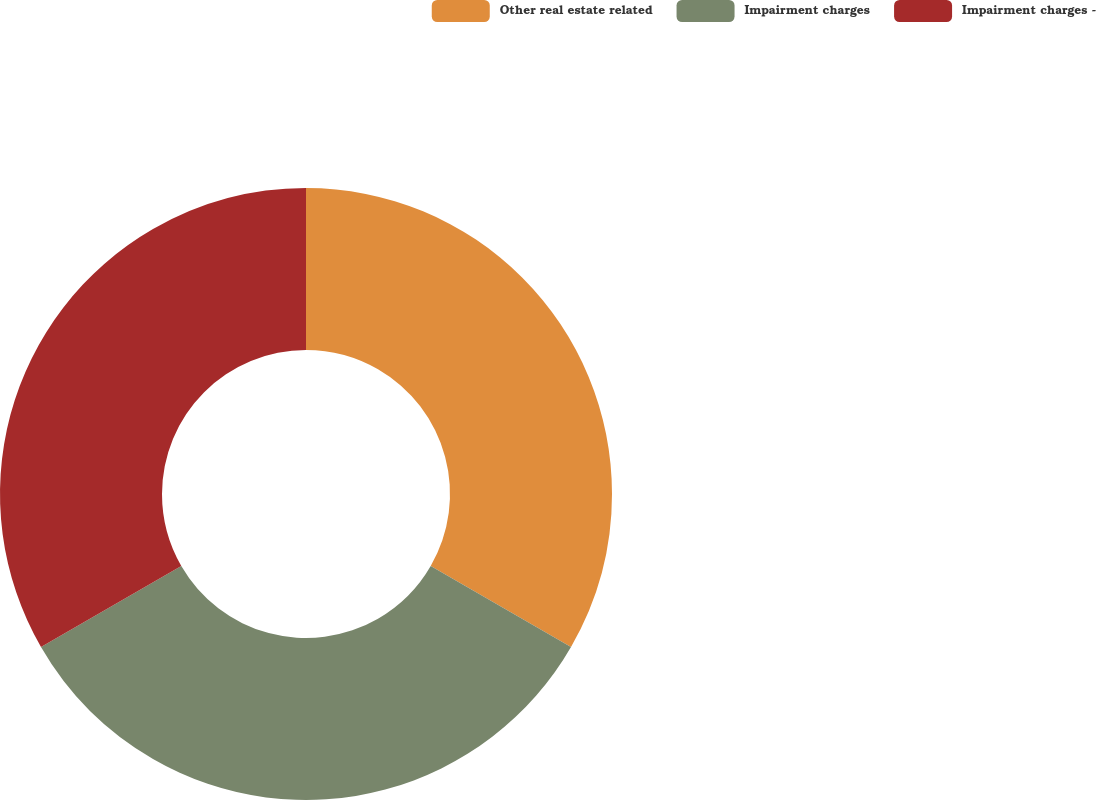<chart> <loc_0><loc_0><loc_500><loc_500><pie_chart><fcel>Other real estate related<fcel>Impairment charges<fcel>Impairment charges -<nl><fcel>33.33%<fcel>33.33%<fcel>33.33%<nl></chart> 